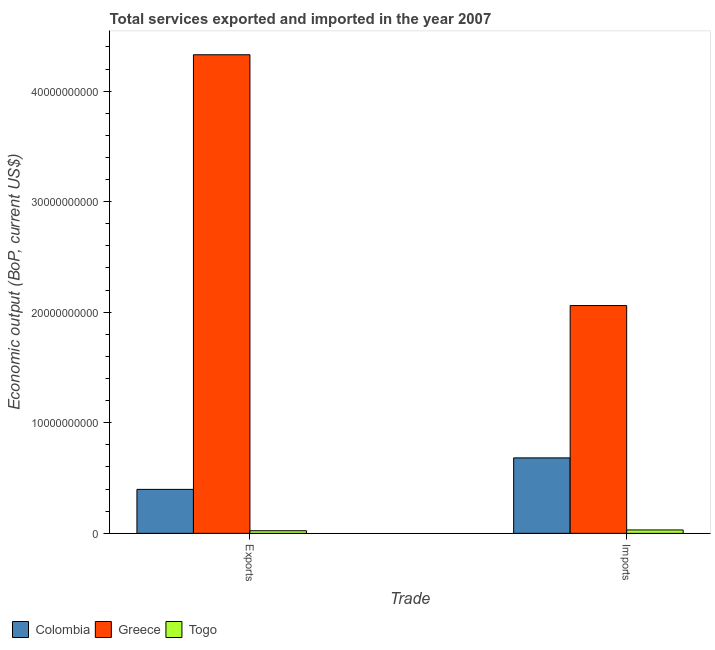How many groups of bars are there?
Provide a short and direct response. 2. Are the number of bars on each tick of the X-axis equal?
Provide a succinct answer. Yes. How many bars are there on the 1st tick from the left?
Provide a succinct answer. 3. What is the label of the 2nd group of bars from the left?
Offer a very short reply. Imports. What is the amount of service imports in Colombia?
Provide a succinct answer. 6.82e+09. Across all countries, what is the maximum amount of service exports?
Your answer should be very brief. 4.33e+1. Across all countries, what is the minimum amount of service exports?
Give a very brief answer. 2.36e+08. In which country was the amount of service imports minimum?
Offer a very short reply. Togo. What is the total amount of service imports in the graph?
Provide a short and direct response. 2.77e+1. What is the difference between the amount of service exports in Greece and that in Togo?
Keep it short and to the point. 4.31e+1. What is the difference between the amount of service imports in Greece and the amount of service exports in Colombia?
Your answer should be compact. 1.66e+1. What is the average amount of service imports per country?
Your response must be concise. 9.24e+09. What is the difference between the amount of service imports and amount of service exports in Colombia?
Offer a very short reply. 2.85e+09. What is the ratio of the amount of service imports in Greece to that in Colombia?
Provide a succinct answer. 3.02. What does the 1st bar from the left in Imports represents?
Offer a terse response. Colombia. How many countries are there in the graph?
Your response must be concise. 3. Does the graph contain grids?
Provide a succinct answer. No. How many legend labels are there?
Your answer should be compact. 3. How are the legend labels stacked?
Offer a very short reply. Horizontal. What is the title of the graph?
Your answer should be very brief. Total services exported and imported in the year 2007. What is the label or title of the X-axis?
Offer a terse response. Trade. What is the label or title of the Y-axis?
Keep it short and to the point. Economic output (BoP, current US$). What is the Economic output (BoP, current US$) in Colombia in Exports?
Your response must be concise. 3.98e+09. What is the Economic output (BoP, current US$) in Greece in Exports?
Offer a terse response. 4.33e+1. What is the Economic output (BoP, current US$) of Togo in Exports?
Your answer should be very brief. 2.36e+08. What is the Economic output (BoP, current US$) of Colombia in Imports?
Offer a terse response. 6.82e+09. What is the Economic output (BoP, current US$) of Greece in Imports?
Give a very brief answer. 2.06e+1. What is the Economic output (BoP, current US$) in Togo in Imports?
Offer a very short reply. 3.05e+08. Across all Trade, what is the maximum Economic output (BoP, current US$) of Colombia?
Your response must be concise. 6.82e+09. Across all Trade, what is the maximum Economic output (BoP, current US$) of Greece?
Make the answer very short. 4.33e+1. Across all Trade, what is the maximum Economic output (BoP, current US$) of Togo?
Offer a terse response. 3.05e+08. Across all Trade, what is the minimum Economic output (BoP, current US$) in Colombia?
Give a very brief answer. 3.98e+09. Across all Trade, what is the minimum Economic output (BoP, current US$) in Greece?
Ensure brevity in your answer.  2.06e+1. Across all Trade, what is the minimum Economic output (BoP, current US$) in Togo?
Provide a short and direct response. 2.36e+08. What is the total Economic output (BoP, current US$) of Colombia in the graph?
Keep it short and to the point. 1.08e+1. What is the total Economic output (BoP, current US$) of Greece in the graph?
Keep it short and to the point. 6.39e+1. What is the total Economic output (BoP, current US$) of Togo in the graph?
Give a very brief answer. 5.41e+08. What is the difference between the Economic output (BoP, current US$) in Colombia in Exports and that in Imports?
Provide a succinct answer. -2.85e+09. What is the difference between the Economic output (BoP, current US$) in Greece in Exports and that in Imports?
Your response must be concise. 2.27e+1. What is the difference between the Economic output (BoP, current US$) in Togo in Exports and that in Imports?
Provide a succinct answer. -6.94e+07. What is the difference between the Economic output (BoP, current US$) of Colombia in Exports and the Economic output (BoP, current US$) of Greece in Imports?
Keep it short and to the point. -1.66e+1. What is the difference between the Economic output (BoP, current US$) in Colombia in Exports and the Economic output (BoP, current US$) in Togo in Imports?
Your response must be concise. 3.67e+09. What is the difference between the Economic output (BoP, current US$) in Greece in Exports and the Economic output (BoP, current US$) in Togo in Imports?
Make the answer very short. 4.30e+1. What is the average Economic output (BoP, current US$) of Colombia per Trade?
Make the answer very short. 5.40e+09. What is the average Economic output (BoP, current US$) in Greece per Trade?
Your answer should be compact. 3.19e+1. What is the average Economic output (BoP, current US$) of Togo per Trade?
Provide a short and direct response. 2.71e+08. What is the difference between the Economic output (BoP, current US$) in Colombia and Economic output (BoP, current US$) in Greece in Exports?
Make the answer very short. -3.93e+1. What is the difference between the Economic output (BoP, current US$) in Colombia and Economic output (BoP, current US$) in Togo in Exports?
Ensure brevity in your answer.  3.74e+09. What is the difference between the Economic output (BoP, current US$) of Greece and Economic output (BoP, current US$) of Togo in Exports?
Provide a short and direct response. 4.31e+1. What is the difference between the Economic output (BoP, current US$) of Colombia and Economic output (BoP, current US$) of Greece in Imports?
Your answer should be compact. -1.38e+1. What is the difference between the Economic output (BoP, current US$) of Colombia and Economic output (BoP, current US$) of Togo in Imports?
Make the answer very short. 6.52e+09. What is the difference between the Economic output (BoP, current US$) in Greece and Economic output (BoP, current US$) in Togo in Imports?
Ensure brevity in your answer.  2.03e+1. What is the ratio of the Economic output (BoP, current US$) of Colombia in Exports to that in Imports?
Ensure brevity in your answer.  0.58. What is the ratio of the Economic output (BoP, current US$) of Greece in Exports to that in Imports?
Offer a very short reply. 2.1. What is the ratio of the Economic output (BoP, current US$) in Togo in Exports to that in Imports?
Your answer should be compact. 0.77. What is the difference between the highest and the second highest Economic output (BoP, current US$) of Colombia?
Provide a succinct answer. 2.85e+09. What is the difference between the highest and the second highest Economic output (BoP, current US$) of Greece?
Ensure brevity in your answer.  2.27e+1. What is the difference between the highest and the second highest Economic output (BoP, current US$) in Togo?
Offer a very short reply. 6.94e+07. What is the difference between the highest and the lowest Economic output (BoP, current US$) of Colombia?
Offer a very short reply. 2.85e+09. What is the difference between the highest and the lowest Economic output (BoP, current US$) in Greece?
Make the answer very short. 2.27e+1. What is the difference between the highest and the lowest Economic output (BoP, current US$) in Togo?
Make the answer very short. 6.94e+07. 